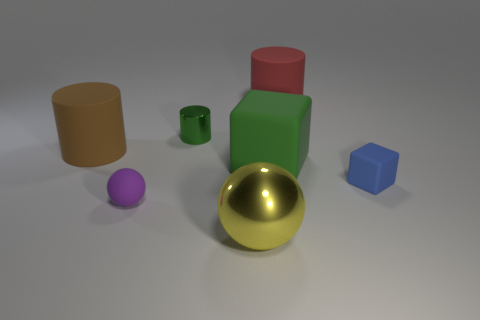Add 1 shiny cubes. How many objects exist? 8 Subtract all spheres. How many objects are left? 5 Add 2 tiny brown metallic things. How many tiny brown metallic things exist? 2 Subtract 1 green cylinders. How many objects are left? 6 Subtract all rubber cylinders. Subtract all large green objects. How many objects are left? 4 Add 5 small cylinders. How many small cylinders are left? 6 